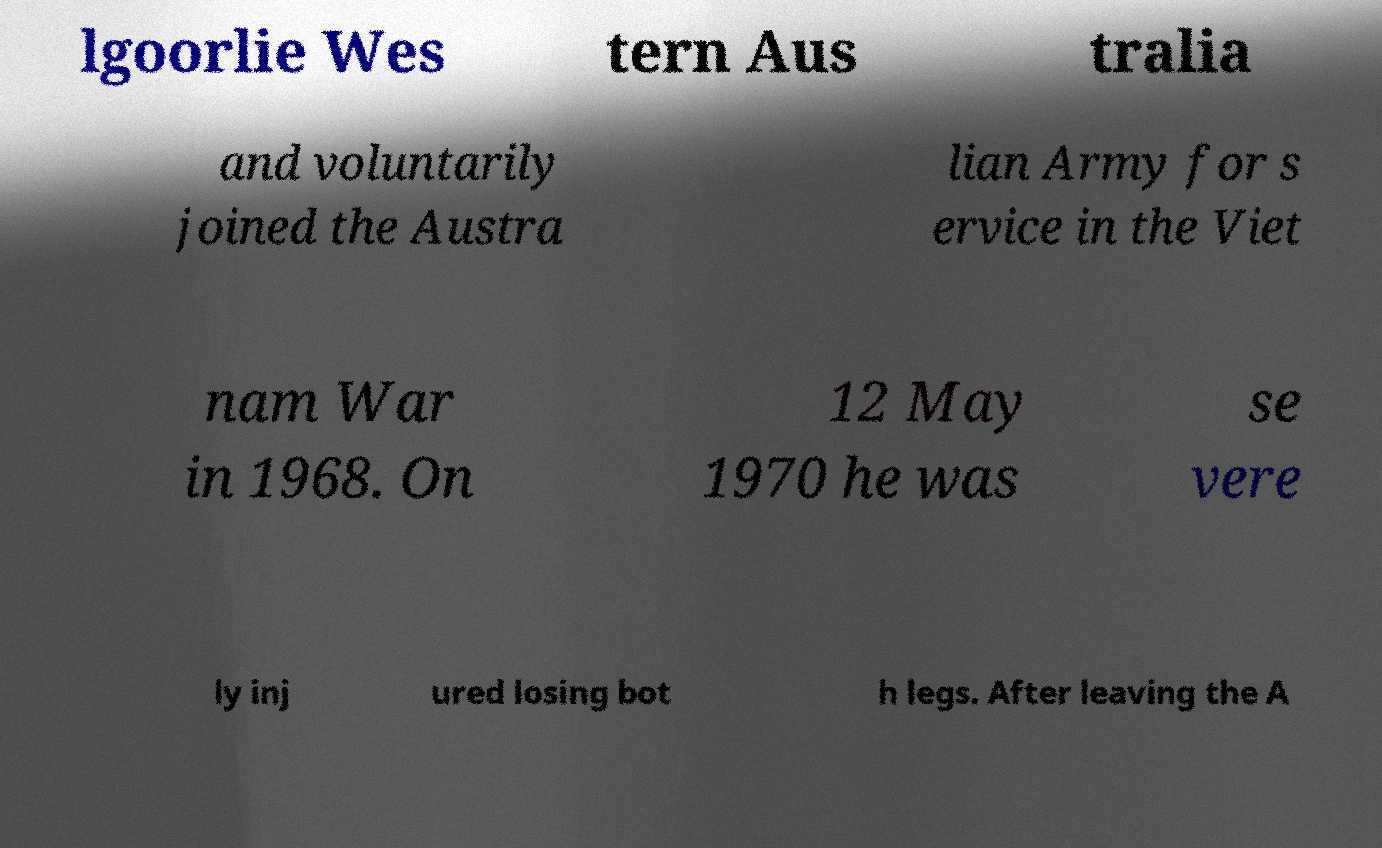Please read and relay the text visible in this image. What does it say? lgoorlie Wes tern Aus tralia and voluntarily joined the Austra lian Army for s ervice in the Viet nam War in 1968. On 12 May 1970 he was se vere ly inj ured losing bot h legs. After leaving the A 